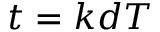<formula> <loc_0><loc_0><loc_500><loc_500>t = k d T</formula> 